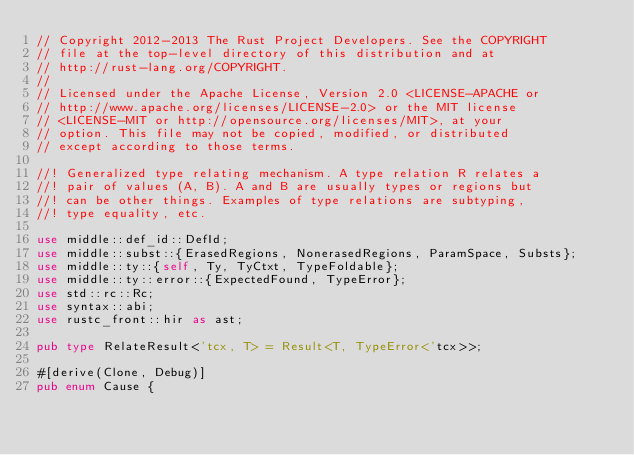Convert code to text. <code><loc_0><loc_0><loc_500><loc_500><_Rust_>// Copyright 2012-2013 The Rust Project Developers. See the COPYRIGHT
// file at the top-level directory of this distribution and at
// http://rust-lang.org/COPYRIGHT.
//
// Licensed under the Apache License, Version 2.0 <LICENSE-APACHE or
// http://www.apache.org/licenses/LICENSE-2.0> or the MIT license
// <LICENSE-MIT or http://opensource.org/licenses/MIT>, at your
// option. This file may not be copied, modified, or distributed
// except according to those terms.

//! Generalized type relating mechanism. A type relation R relates a
//! pair of values (A, B). A and B are usually types or regions but
//! can be other things. Examples of type relations are subtyping,
//! type equality, etc.

use middle::def_id::DefId;
use middle::subst::{ErasedRegions, NonerasedRegions, ParamSpace, Substs};
use middle::ty::{self, Ty, TyCtxt, TypeFoldable};
use middle::ty::error::{ExpectedFound, TypeError};
use std::rc::Rc;
use syntax::abi;
use rustc_front::hir as ast;

pub type RelateResult<'tcx, T> = Result<T, TypeError<'tcx>>;

#[derive(Clone, Debug)]
pub enum Cause {</code> 